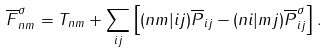Convert formula to latex. <formula><loc_0><loc_0><loc_500><loc_500>\overline { F } ^ { \sigma } _ { n m } = T _ { n m } + \sum _ { i j } \left [ ( n m | i j ) \overline { P } _ { i j } - ( n i | m j ) \overline { P } ^ { \sigma } _ { i j } \right ] .</formula> 